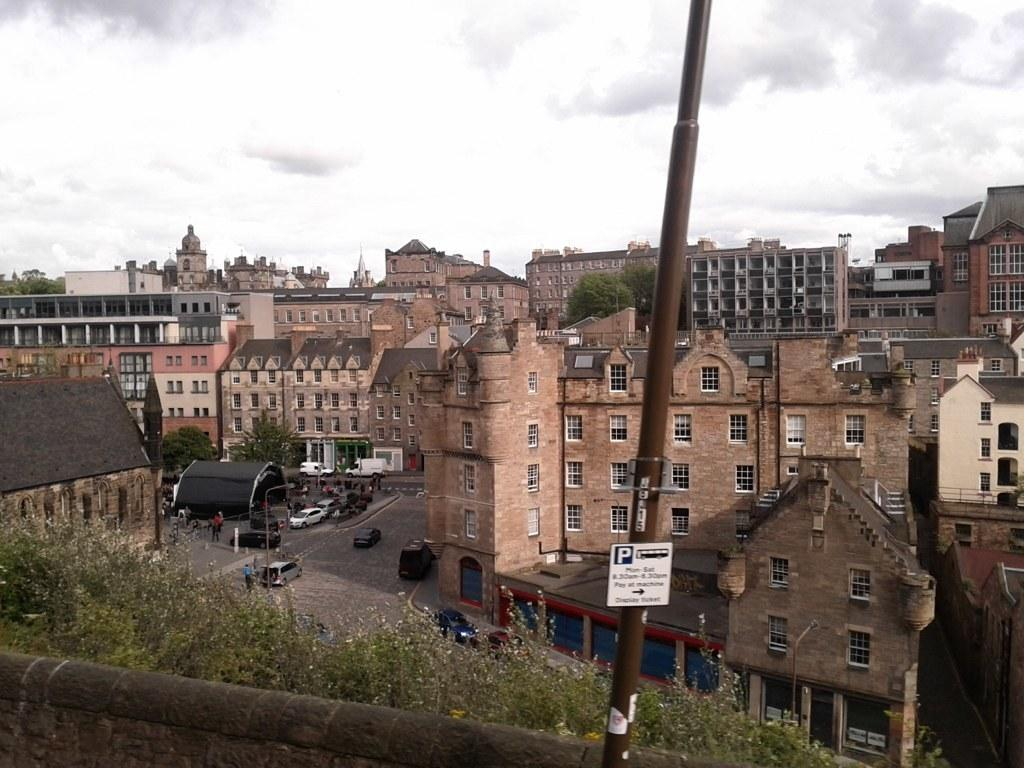What can be seen on the road in the image? There are cars on the road in the image. What is visible in the background of the image? There are buildings, trees, and the sky visible in the background of the image. Can you see the father swimming in the ocean in the image? There is no father or ocean present in the image. How many bananas are hanging from the trees in the background? There are no bananas visible in the image; only trees are present. 